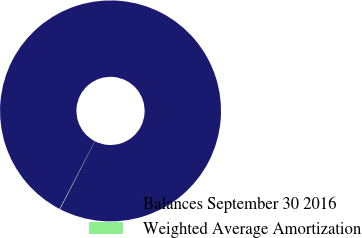<chart> <loc_0><loc_0><loc_500><loc_500><pie_chart><fcel>Balances September 30 2016<fcel>Weighted Average Amortization<nl><fcel>99.94%<fcel>0.06%<nl></chart> 